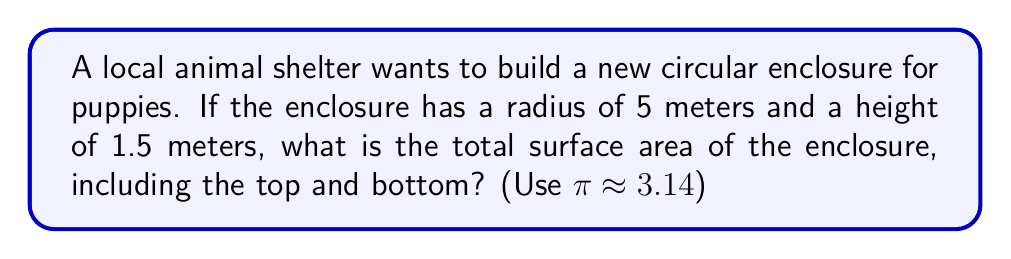What is the answer to this math problem? Let's break this down step-by-step:

1) The enclosure is a circular cylinder. To find its surface area, we need to calculate:
   a) The area of the top and bottom circles
   b) The area of the curved side (lateral area)

2) For the circular top and bottom:
   - Area of a circle = $\pi r^2$
   - Radius (r) = 5 meters
   - Area of one circle = $\pi (5)^2 = 25\pi$ m²
   - We have two circles (top and bottom), so total area = $2(25\pi)$ = $50\pi$ m²

3) For the curved side (lateral area):
   - Area of a rectangle = length × width
   - The length is the circumference of the circle: $2\pi r = 2\pi(5) = 10\pi$ m
   - The width is the height of the enclosure: 1.5 m
   - Lateral area = $10\pi \times 1.5 = 15\pi$ m²

4) Total surface area:
   - Sum of all areas = Area of top and bottom + Lateral area
   - Total surface area = $50\pi + 15\pi = 65\pi$ m²

5) Using $\pi \approx 3.14$:
   Total surface area $\approx 65 \times 3.14 = 204.1$ m²
Answer: $204.1$ m² 